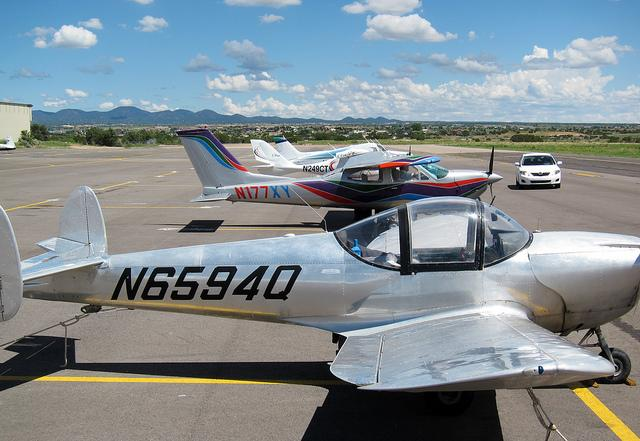What are cables hooked to these planes for?

Choices:
A) kite flying
B) sales gimmick
C) holding steady
D) racing feature holding steady 